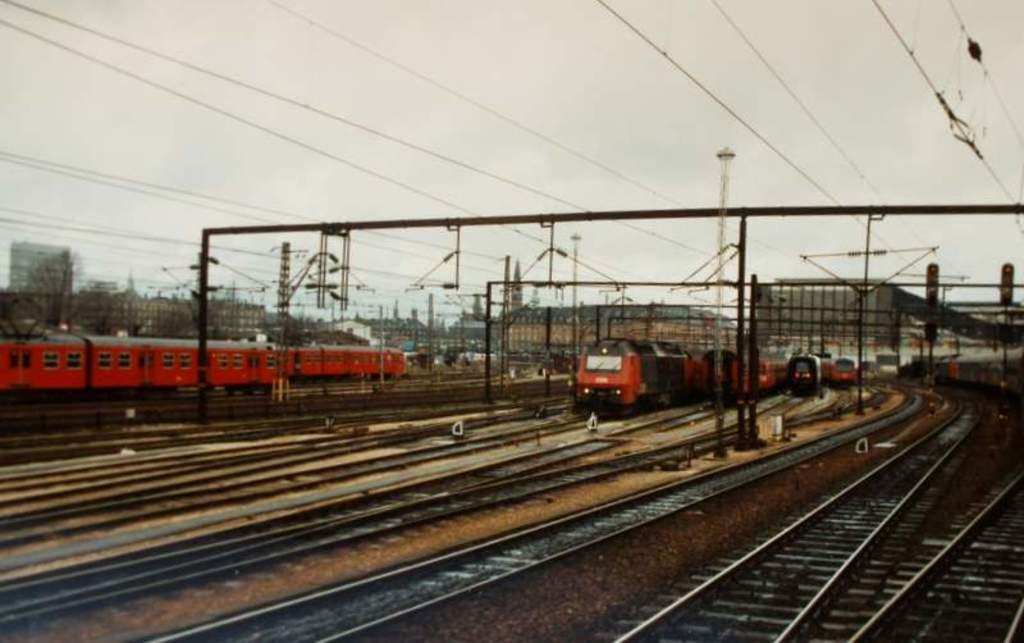What can be seen on the tracks in the image? There are trains on the tracks in the image. What type of structures are present in the image? There are metal frames in the image. What can be seen in the background of the image? Wires and the sky are visible in the background of the image. What type of space vessel is visible in the image? There is no space vessel present in the image; it features tracks, trains, metal frames, wires, and the sky. Can you tell me the name of the secretary in the image? There is no secretary present in the image. 